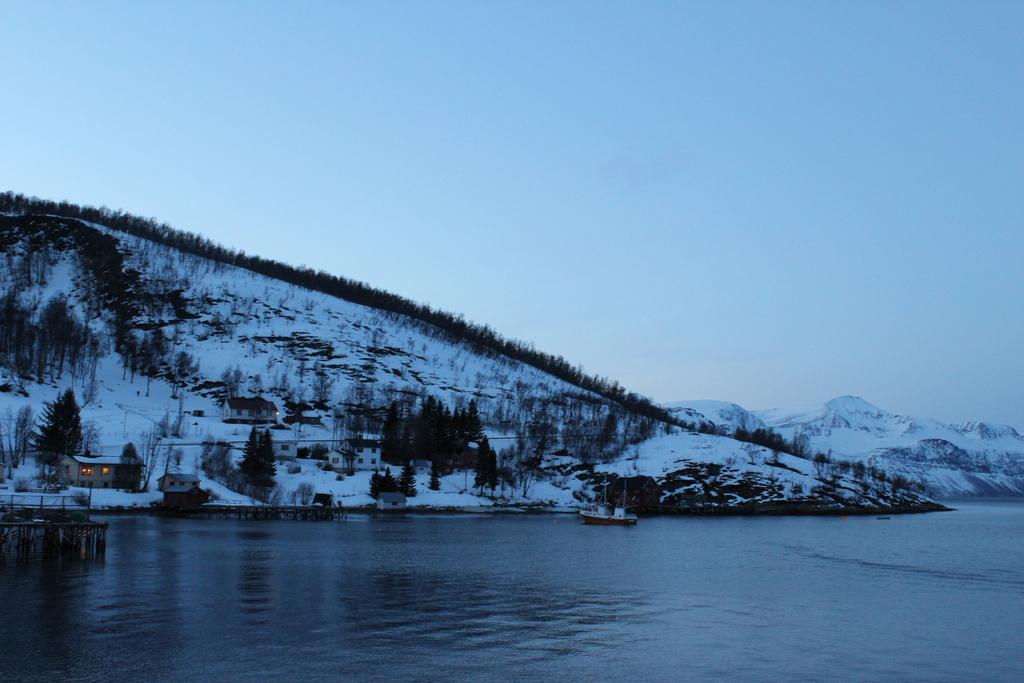Please provide a concise description of this image. In this picture we can see water at the bottom, there is a boat here, on the left side there is a house, we can see snow here, in the background there are some trees, we can see the sky at the top of the picture. 